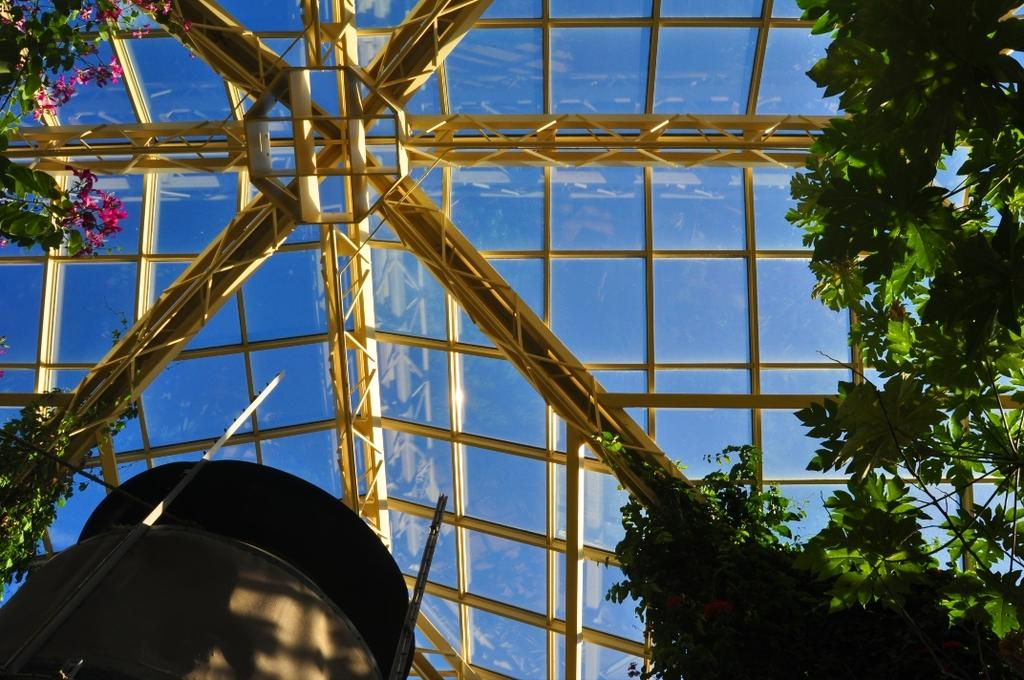What is located in the center of the image? There are rods in the center of the image. What type of vegetation can be seen in the image? There is grass visible in the image. What type of construction is at the bottom of the image? There is a cement construction at the bottom of the image. What other natural elements are present in the image? There are trees in the image. What month is it in the image? The month cannot be determined from the image, as it does not contain any information about the time of year. 